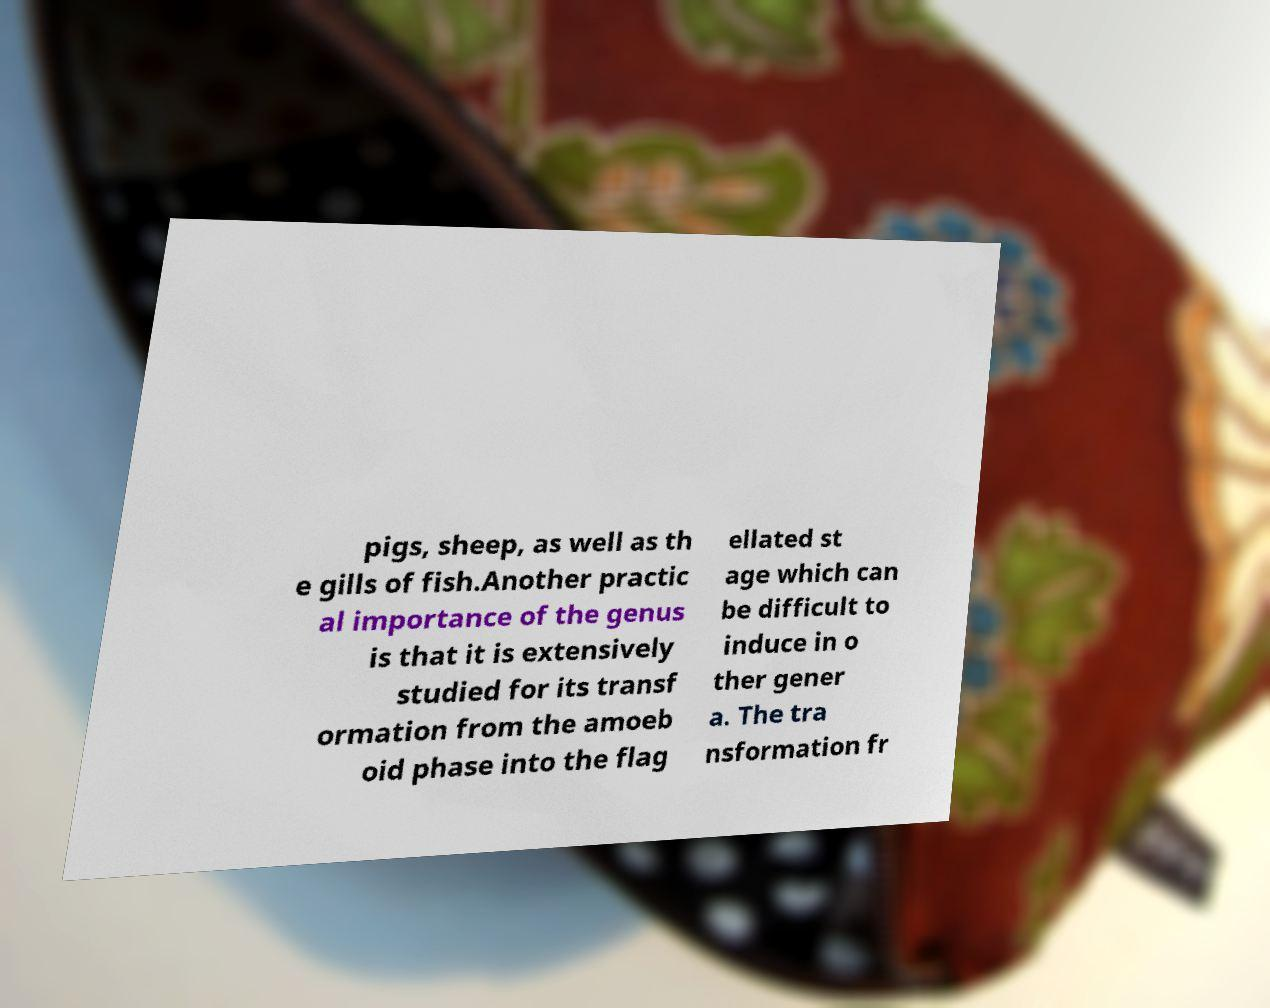Can you accurately transcribe the text from the provided image for me? pigs, sheep, as well as th e gills of fish.Another practic al importance of the genus is that it is extensively studied for its transf ormation from the amoeb oid phase into the flag ellated st age which can be difficult to induce in o ther gener a. The tra nsformation fr 